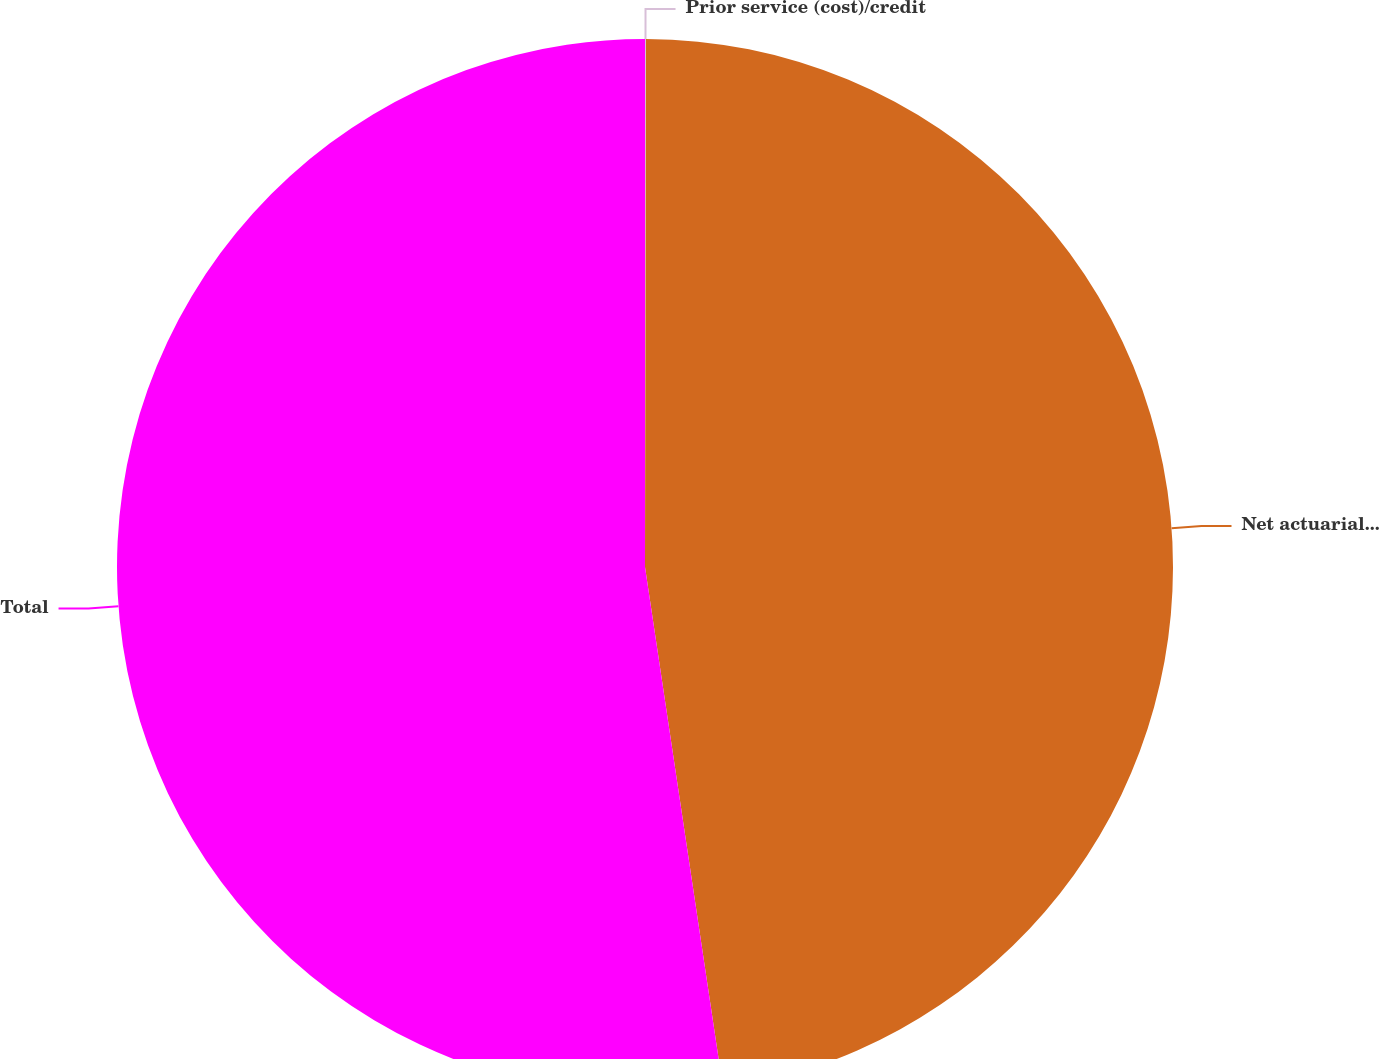Convert chart to OTSL. <chart><loc_0><loc_0><loc_500><loc_500><pie_chart><fcel>Prior service (cost)/credit<fcel>Net actuarial loss<fcel>Total<nl><fcel>0.03%<fcel>47.6%<fcel>52.36%<nl></chart> 